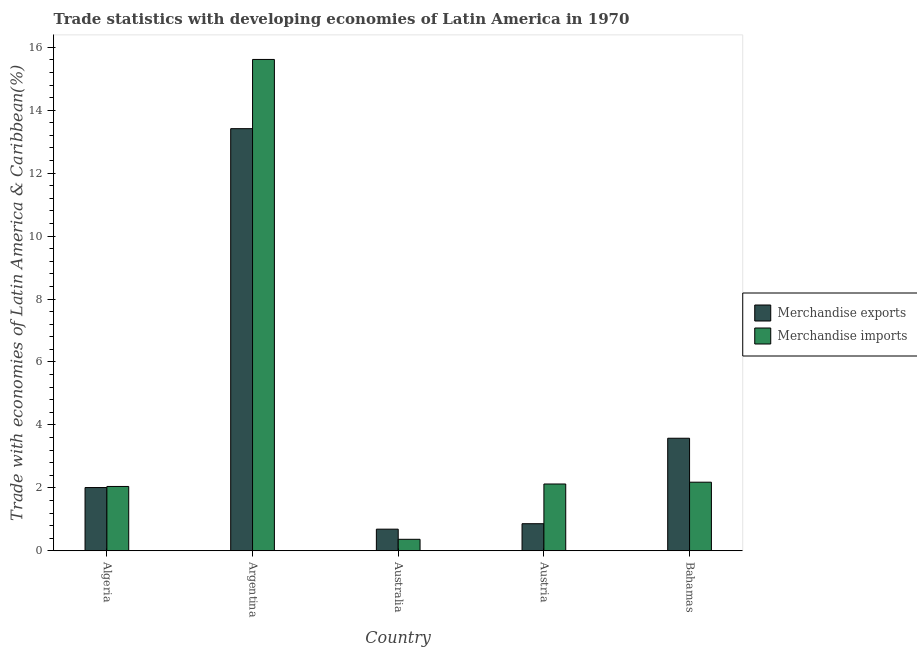How many groups of bars are there?
Keep it short and to the point. 5. Are the number of bars on each tick of the X-axis equal?
Make the answer very short. Yes. In how many cases, is the number of bars for a given country not equal to the number of legend labels?
Your answer should be very brief. 0. What is the merchandise imports in Algeria?
Your answer should be compact. 2.04. Across all countries, what is the maximum merchandise exports?
Your answer should be very brief. 13.41. Across all countries, what is the minimum merchandise exports?
Provide a succinct answer. 0.69. In which country was the merchandise imports maximum?
Your response must be concise. Argentina. What is the total merchandise exports in the graph?
Make the answer very short. 20.55. What is the difference between the merchandise imports in Algeria and that in Austria?
Your answer should be compact. -0.08. What is the difference between the merchandise imports in Bahamas and the merchandise exports in Algeria?
Make the answer very short. 0.17. What is the average merchandise imports per country?
Ensure brevity in your answer.  4.46. What is the difference between the merchandise exports and merchandise imports in Argentina?
Your answer should be very brief. -2.2. What is the ratio of the merchandise imports in Algeria to that in Austria?
Ensure brevity in your answer.  0.96. Is the difference between the merchandise imports in Algeria and Bahamas greater than the difference between the merchandise exports in Algeria and Bahamas?
Keep it short and to the point. Yes. What is the difference between the highest and the second highest merchandise imports?
Ensure brevity in your answer.  13.43. What is the difference between the highest and the lowest merchandise imports?
Your answer should be very brief. 15.25. Is the sum of the merchandise exports in Argentina and Austria greater than the maximum merchandise imports across all countries?
Offer a very short reply. No. What does the 2nd bar from the right in Australia represents?
Make the answer very short. Merchandise exports. Are all the bars in the graph horizontal?
Your answer should be very brief. No. How many countries are there in the graph?
Your answer should be very brief. 5. What is the difference between two consecutive major ticks on the Y-axis?
Offer a very short reply. 2. Are the values on the major ticks of Y-axis written in scientific E-notation?
Ensure brevity in your answer.  No. Does the graph contain any zero values?
Keep it short and to the point. No. Does the graph contain grids?
Provide a succinct answer. No. What is the title of the graph?
Offer a terse response. Trade statistics with developing economies of Latin America in 1970. Does "Mobile cellular" appear as one of the legend labels in the graph?
Keep it short and to the point. No. What is the label or title of the Y-axis?
Provide a short and direct response. Trade with economies of Latin America & Caribbean(%). What is the Trade with economies of Latin America & Caribbean(%) in Merchandise exports in Algeria?
Provide a short and direct response. 2.01. What is the Trade with economies of Latin America & Caribbean(%) in Merchandise imports in Algeria?
Offer a terse response. 2.04. What is the Trade with economies of Latin America & Caribbean(%) of Merchandise exports in Argentina?
Your response must be concise. 13.41. What is the Trade with economies of Latin America & Caribbean(%) of Merchandise imports in Argentina?
Offer a very short reply. 15.61. What is the Trade with economies of Latin America & Caribbean(%) in Merchandise exports in Australia?
Provide a succinct answer. 0.69. What is the Trade with economies of Latin America & Caribbean(%) of Merchandise imports in Australia?
Ensure brevity in your answer.  0.36. What is the Trade with economies of Latin America & Caribbean(%) in Merchandise exports in Austria?
Provide a short and direct response. 0.86. What is the Trade with economies of Latin America & Caribbean(%) of Merchandise imports in Austria?
Give a very brief answer. 2.12. What is the Trade with economies of Latin America & Caribbean(%) of Merchandise exports in Bahamas?
Your answer should be compact. 3.58. What is the Trade with economies of Latin America & Caribbean(%) in Merchandise imports in Bahamas?
Provide a succinct answer. 2.18. Across all countries, what is the maximum Trade with economies of Latin America & Caribbean(%) of Merchandise exports?
Offer a terse response. 13.41. Across all countries, what is the maximum Trade with economies of Latin America & Caribbean(%) in Merchandise imports?
Your answer should be compact. 15.61. Across all countries, what is the minimum Trade with economies of Latin America & Caribbean(%) in Merchandise exports?
Make the answer very short. 0.69. Across all countries, what is the minimum Trade with economies of Latin America & Caribbean(%) of Merchandise imports?
Provide a short and direct response. 0.36. What is the total Trade with economies of Latin America & Caribbean(%) of Merchandise exports in the graph?
Make the answer very short. 20.55. What is the total Trade with economies of Latin America & Caribbean(%) of Merchandise imports in the graph?
Your answer should be very brief. 22.32. What is the difference between the Trade with economies of Latin America & Caribbean(%) in Merchandise exports in Algeria and that in Argentina?
Keep it short and to the point. -11.41. What is the difference between the Trade with economies of Latin America & Caribbean(%) in Merchandise imports in Algeria and that in Argentina?
Offer a very short reply. -13.57. What is the difference between the Trade with economies of Latin America & Caribbean(%) in Merchandise exports in Algeria and that in Australia?
Provide a succinct answer. 1.32. What is the difference between the Trade with economies of Latin America & Caribbean(%) of Merchandise imports in Algeria and that in Australia?
Give a very brief answer. 1.68. What is the difference between the Trade with economies of Latin America & Caribbean(%) in Merchandise exports in Algeria and that in Austria?
Your response must be concise. 1.15. What is the difference between the Trade with economies of Latin America & Caribbean(%) of Merchandise imports in Algeria and that in Austria?
Make the answer very short. -0.08. What is the difference between the Trade with economies of Latin America & Caribbean(%) of Merchandise exports in Algeria and that in Bahamas?
Ensure brevity in your answer.  -1.57. What is the difference between the Trade with economies of Latin America & Caribbean(%) of Merchandise imports in Algeria and that in Bahamas?
Make the answer very short. -0.14. What is the difference between the Trade with economies of Latin America & Caribbean(%) of Merchandise exports in Argentina and that in Australia?
Give a very brief answer. 12.73. What is the difference between the Trade with economies of Latin America & Caribbean(%) of Merchandise imports in Argentina and that in Australia?
Offer a very short reply. 15.25. What is the difference between the Trade with economies of Latin America & Caribbean(%) of Merchandise exports in Argentina and that in Austria?
Keep it short and to the point. 12.55. What is the difference between the Trade with economies of Latin America & Caribbean(%) in Merchandise imports in Argentina and that in Austria?
Make the answer very short. 13.49. What is the difference between the Trade with economies of Latin America & Caribbean(%) of Merchandise exports in Argentina and that in Bahamas?
Your response must be concise. 9.84. What is the difference between the Trade with economies of Latin America & Caribbean(%) of Merchandise imports in Argentina and that in Bahamas?
Give a very brief answer. 13.43. What is the difference between the Trade with economies of Latin America & Caribbean(%) of Merchandise exports in Australia and that in Austria?
Ensure brevity in your answer.  -0.17. What is the difference between the Trade with economies of Latin America & Caribbean(%) of Merchandise imports in Australia and that in Austria?
Make the answer very short. -1.76. What is the difference between the Trade with economies of Latin America & Caribbean(%) of Merchandise exports in Australia and that in Bahamas?
Offer a terse response. -2.89. What is the difference between the Trade with economies of Latin America & Caribbean(%) of Merchandise imports in Australia and that in Bahamas?
Give a very brief answer. -1.81. What is the difference between the Trade with economies of Latin America & Caribbean(%) of Merchandise exports in Austria and that in Bahamas?
Your answer should be very brief. -2.72. What is the difference between the Trade with economies of Latin America & Caribbean(%) of Merchandise imports in Austria and that in Bahamas?
Your response must be concise. -0.06. What is the difference between the Trade with economies of Latin America & Caribbean(%) of Merchandise exports in Algeria and the Trade with economies of Latin America & Caribbean(%) of Merchandise imports in Argentina?
Keep it short and to the point. -13.6. What is the difference between the Trade with economies of Latin America & Caribbean(%) of Merchandise exports in Algeria and the Trade with economies of Latin America & Caribbean(%) of Merchandise imports in Australia?
Your response must be concise. 1.64. What is the difference between the Trade with economies of Latin America & Caribbean(%) of Merchandise exports in Algeria and the Trade with economies of Latin America & Caribbean(%) of Merchandise imports in Austria?
Keep it short and to the point. -0.11. What is the difference between the Trade with economies of Latin America & Caribbean(%) in Merchandise exports in Algeria and the Trade with economies of Latin America & Caribbean(%) in Merchandise imports in Bahamas?
Your response must be concise. -0.17. What is the difference between the Trade with economies of Latin America & Caribbean(%) in Merchandise exports in Argentina and the Trade with economies of Latin America & Caribbean(%) in Merchandise imports in Australia?
Offer a terse response. 13.05. What is the difference between the Trade with economies of Latin America & Caribbean(%) of Merchandise exports in Argentina and the Trade with economies of Latin America & Caribbean(%) of Merchandise imports in Austria?
Offer a very short reply. 11.29. What is the difference between the Trade with economies of Latin America & Caribbean(%) in Merchandise exports in Argentina and the Trade with economies of Latin America & Caribbean(%) in Merchandise imports in Bahamas?
Your response must be concise. 11.24. What is the difference between the Trade with economies of Latin America & Caribbean(%) in Merchandise exports in Australia and the Trade with economies of Latin America & Caribbean(%) in Merchandise imports in Austria?
Offer a very short reply. -1.44. What is the difference between the Trade with economies of Latin America & Caribbean(%) in Merchandise exports in Australia and the Trade with economies of Latin America & Caribbean(%) in Merchandise imports in Bahamas?
Give a very brief answer. -1.49. What is the difference between the Trade with economies of Latin America & Caribbean(%) in Merchandise exports in Austria and the Trade with economies of Latin America & Caribbean(%) in Merchandise imports in Bahamas?
Your response must be concise. -1.32. What is the average Trade with economies of Latin America & Caribbean(%) in Merchandise exports per country?
Your response must be concise. 4.11. What is the average Trade with economies of Latin America & Caribbean(%) of Merchandise imports per country?
Keep it short and to the point. 4.46. What is the difference between the Trade with economies of Latin America & Caribbean(%) in Merchandise exports and Trade with economies of Latin America & Caribbean(%) in Merchandise imports in Algeria?
Offer a very short reply. -0.03. What is the difference between the Trade with economies of Latin America & Caribbean(%) in Merchandise exports and Trade with economies of Latin America & Caribbean(%) in Merchandise imports in Argentina?
Keep it short and to the point. -2.2. What is the difference between the Trade with economies of Latin America & Caribbean(%) in Merchandise exports and Trade with economies of Latin America & Caribbean(%) in Merchandise imports in Australia?
Provide a succinct answer. 0.32. What is the difference between the Trade with economies of Latin America & Caribbean(%) of Merchandise exports and Trade with economies of Latin America & Caribbean(%) of Merchandise imports in Austria?
Provide a short and direct response. -1.26. What is the difference between the Trade with economies of Latin America & Caribbean(%) of Merchandise exports and Trade with economies of Latin America & Caribbean(%) of Merchandise imports in Bahamas?
Offer a terse response. 1.4. What is the ratio of the Trade with economies of Latin America & Caribbean(%) of Merchandise exports in Algeria to that in Argentina?
Your response must be concise. 0.15. What is the ratio of the Trade with economies of Latin America & Caribbean(%) of Merchandise imports in Algeria to that in Argentina?
Ensure brevity in your answer.  0.13. What is the ratio of the Trade with economies of Latin America & Caribbean(%) of Merchandise exports in Algeria to that in Australia?
Your answer should be very brief. 2.92. What is the ratio of the Trade with economies of Latin America & Caribbean(%) in Merchandise imports in Algeria to that in Australia?
Your answer should be very brief. 5.6. What is the ratio of the Trade with economies of Latin America & Caribbean(%) of Merchandise exports in Algeria to that in Austria?
Your answer should be compact. 2.34. What is the ratio of the Trade with economies of Latin America & Caribbean(%) in Merchandise imports in Algeria to that in Austria?
Make the answer very short. 0.96. What is the ratio of the Trade with economies of Latin America & Caribbean(%) in Merchandise exports in Algeria to that in Bahamas?
Offer a terse response. 0.56. What is the ratio of the Trade with economies of Latin America & Caribbean(%) of Merchandise imports in Algeria to that in Bahamas?
Your answer should be compact. 0.94. What is the ratio of the Trade with economies of Latin America & Caribbean(%) in Merchandise exports in Argentina to that in Australia?
Your response must be concise. 19.53. What is the ratio of the Trade with economies of Latin America & Caribbean(%) of Merchandise imports in Argentina to that in Australia?
Offer a very short reply. 42.82. What is the ratio of the Trade with economies of Latin America & Caribbean(%) in Merchandise exports in Argentina to that in Austria?
Provide a succinct answer. 15.6. What is the ratio of the Trade with economies of Latin America & Caribbean(%) in Merchandise imports in Argentina to that in Austria?
Give a very brief answer. 7.36. What is the ratio of the Trade with economies of Latin America & Caribbean(%) of Merchandise exports in Argentina to that in Bahamas?
Provide a short and direct response. 3.75. What is the ratio of the Trade with economies of Latin America & Caribbean(%) in Merchandise imports in Argentina to that in Bahamas?
Offer a terse response. 7.16. What is the ratio of the Trade with economies of Latin America & Caribbean(%) in Merchandise exports in Australia to that in Austria?
Offer a very short reply. 0.8. What is the ratio of the Trade with economies of Latin America & Caribbean(%) of Merchandise imports in Australia to that in Austria?
Your response must be concise. 0.17. What is the ratio of the Trade with economies of Latin America & Caribbean(%) in Merchandise exports in Australia to that in Bahamas?
Make the answer very short. 0.19. What is the ratio of the Trade with economies of Latin America & Caribbean(%) in Merchandise imports in Australia to that in Bahamas?
Provide a short and direct response. 0.17. What is the ratio of the Trade with economies of Latin America & Caribbean(%) of Merchandise exports in Austria to that in Bahamas?
Your answer should be very brief. 0.24. What is the ratio of the Trade with economies of Latin America & Caribbean(%) in Merchandise imports in Austria to that in Bahamas?
Make the answer very short. 0.97. What is the difference between the highest and the second highest Trade with economies of Latin America & Caribbean(%) in Merchandise exports?
Your answer should be compact. 9.84. What is the difference between the highest and the second highest Trade with economies of Latin America & Caribbean(%) of Merchandise imports?
Give a very brief answer. 13.43. What is the difference between the highest and the lowest Trade with economies of Latin America & Caribbean(%) in Merchandise exports?
Your answer should be very brief. 12.73. What is the difference between the highest and the lowest Trade with economies of Latin America & Caribbean(%) in Merchandise imports?
Your response must be concise. 15.25. 